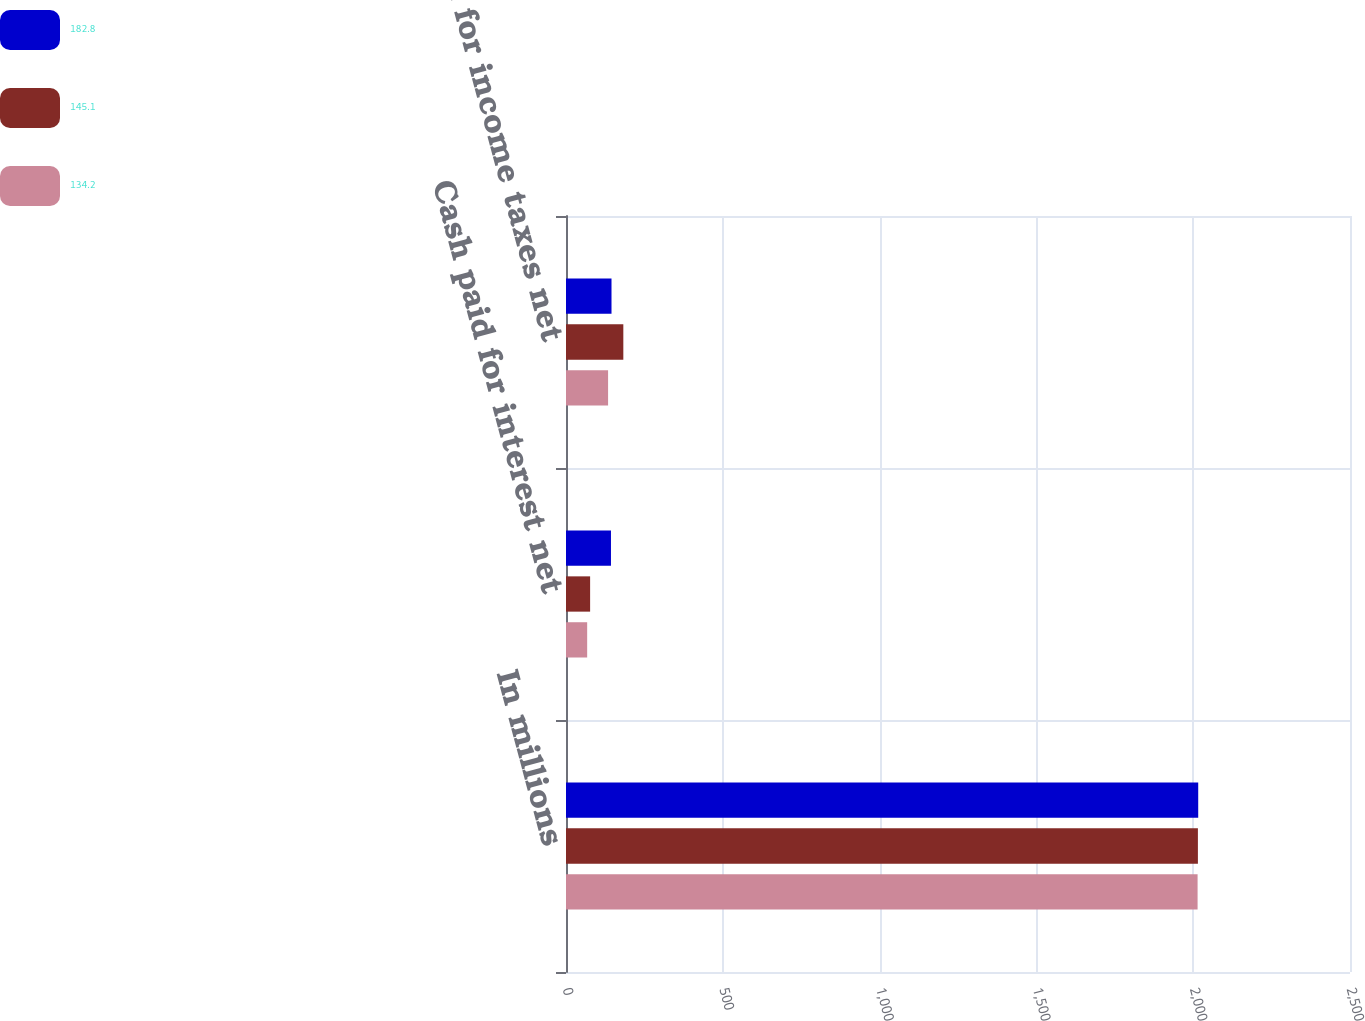Convert chart to OTSL. <chart><loc_0><loc_0><loc_500><loc_500><stacked_bar_chart><ecel><fcel>In millions<fcel>Cash paid for interest net<fcel>Cash paid for income taxes net<nl><fcel>182.8<fcel>2016<fcel>143.4<fcel>145.1<nl><fcel>145.1<fcel>2015<fcel>76.9<fcel>182.8<nl><fcel>134.2<fcel>2014<fcel>67.5<fcel>134.2<nl></chart> 